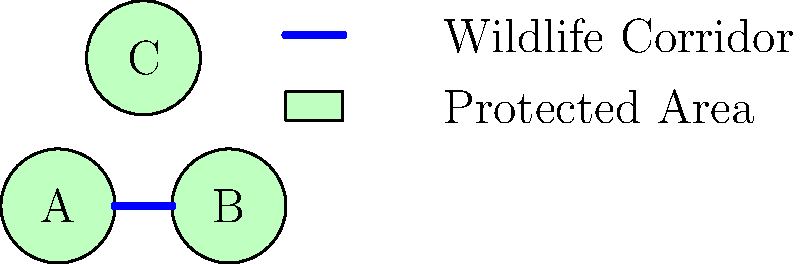In the simplified geographical diagram above, three protected areas (A, B, and C) are shown along with a wildlife corridor connecting two of them. What is the most effective strategy to enhance connectivity between all three protected areas while minimizing the total length of additional corridors needed? To answer this question, we need to consider the principles of wildlife corridor design and the concept of connectivity in landscape ecology. Let's approach this step-by-step:

1. Analyze the current situation:
   - There are three protected areas: A, B, and C.
   - A wildlife corridor already connects A and B.

2. Identify the missing connections:
   - There is no direct connection to area C.

3. Consider the goal:
   - We need to connect all three areas.
   - We want to minimize the total length of additional corridors.

4. Evaluate possible solutions:
   - Option 1: Connect B to C
   - Option 2: Connect A to C

5. Compare the options:
   - Connecting B to C would require a longer corridor than connecting A to C.
   - A to C is the shorter distance and would create a more direct path.

6. Consider the overall network:
   - Connecting A to C would create a triangular network.
   - This triangular configuration provides multiple pathways for wildlife movement.

7. Assess the benefits:
   - A triangular network increases resilience.
   - It offers alternative routes if one corridor is disrupted.

8. Final strategy:
   - The most effective strategy is to add a single corridor connecting A to C.
   - This minimizes additional corridor length while maximizing connectivity.

This approach aligns with the principles of conservation biology and landscape ecology, emphasizing the importance of creating a network of protected areas connected by wildlife corridors to facilitate species movement and genetic exchange.
Answer: Add a corridor connecting protected areas A and C. 